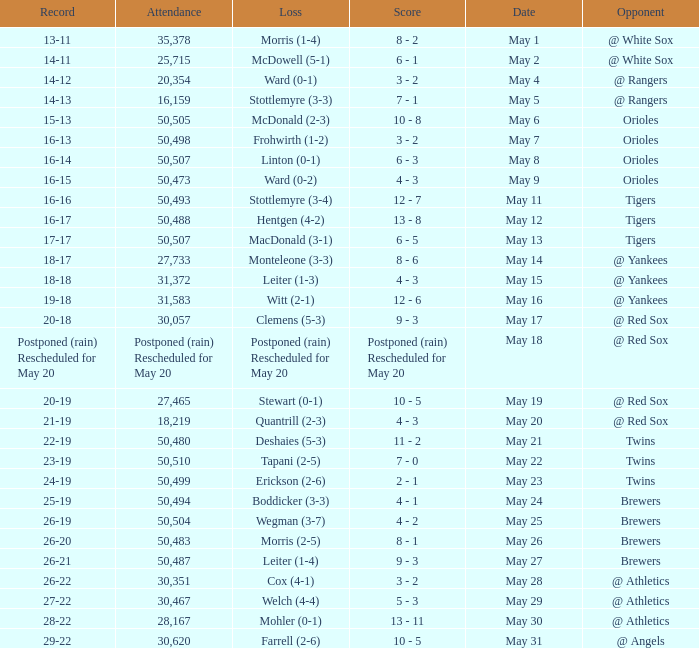On what date was their record 26-19? May 25. 